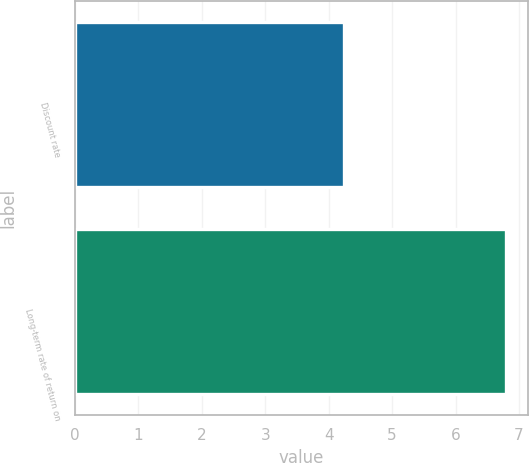Convert chart. <chart><loc_0><loc_0><loc_500><loc_500><bar_chart><fcel>Discount rate<fcel>Long-term rate of return on<nl><fcel>4.24<fcel>6.8<nl></chart> 